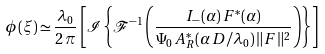<formula> <loc_0><loc_0><loc_500><loc_500>\phi ( \xi ) \simeq \frac { \lambda _ { 0 } } { 2 \, \pi } \left [ \mathcal { I } \left \{ \mathcal { F } ^ { - 1 } \left ( \frac { I _ { - } ( \alpha ) \, F ^ { * } ( \alpha ) } { \Psi _ { 0 } \, A _ { R } ^ { * } ( \alpha \, D / \lambda _ { 0 } ) \, \| F \| ^ { 2 } } \right ) \right \} \right ]</formula> 